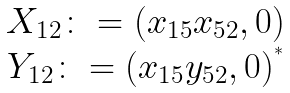Convert formula to latex. <formula><loc_0><loc_0><loc_500><loc_500>\begin{matrix} X _ { 1 2 } \colon = ( x _ { 1 5 } x _ { 5 2 } , 0 ) \\ Y _ { 1 2 } \colon = ( x _ { 1 5 } y _ { 5 2 } , 0 ) ^ { ^ { * } } \end{matrix}</formula> 